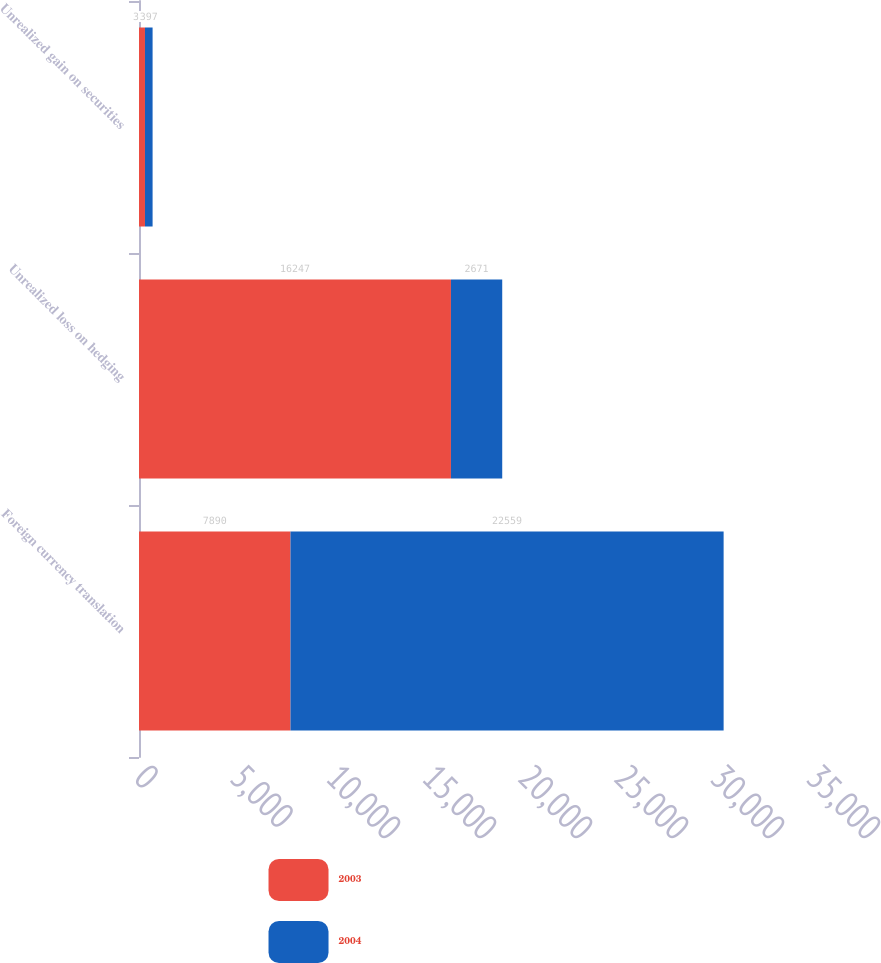<chart> <loc_0><loc_0><loc_500><loc_500><stacked_bar_chart><ecel><fcel>Foreign currency translation<fcel>Unrealized loss on hedging<fcel>Unrealized gain on securities<nl><fcel>2003<fcel>7890<fcel>16247<fcel>311<nl><fcel>2004<fcel>22559<fcel>2671<fcel>397<nl></chart> 